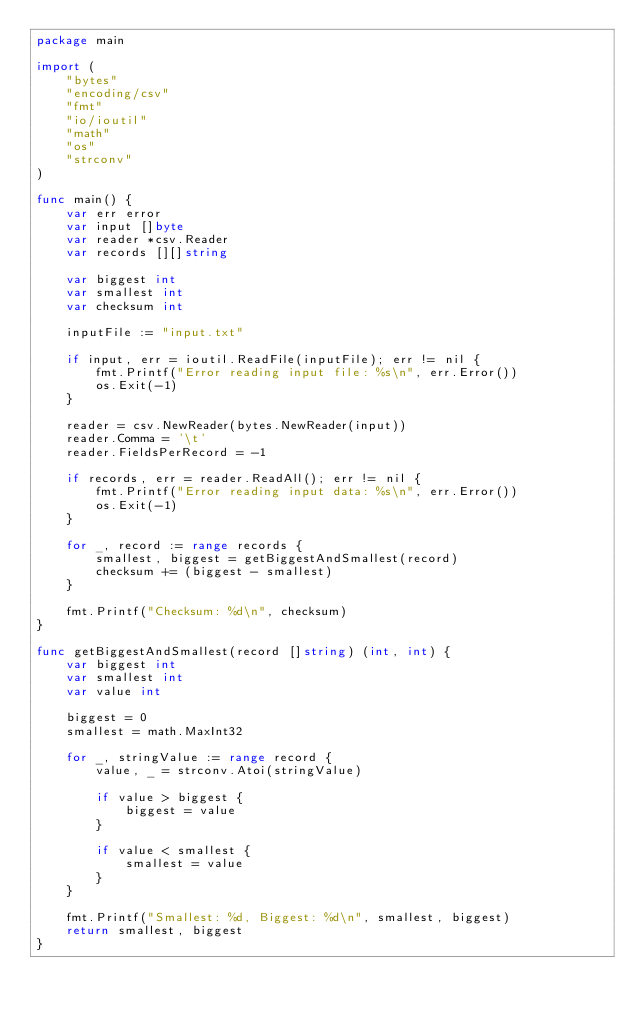<code> <loc_0><loc_0><loc_500><loc_500><_Go_>package main

import (
	"bytes"
	"encoding/csv"
	"fmt"
	"io/ioutil"
	"math"
	"os"
	"strconv"
)

func main() {
	var err error
	var input []byte
	var reader *csv.Reader
	var records [][]string

	var biggest int
	var smallest int
	var checksum int

	inputFile := "input.txt"

	if input, err = ioutil.ReadFile(inputFile); err != nil {
		fmt.Printf("Error reading input file: %s\n", err.Error())
		os.Exit(-1)
	}

	reader = csv.NewReader(bytes.NewReader(input))
	reader.Comma = '\t'
	reader.FieldsPerRecord = -1

	if records, err = reader.ReadAll(); err != nil {
		fmt.Printf("Error reading input data: %s\n", err.Error())
		os.Exit(-1)
	}

	for _, record := range records {
		smallest, biggest = getBiggestAndSmallest(record)
		checksum += (biggest - smallest)
	}

	fmt.Printf("Checksum: %d\n", checksum)
}

func getBiggestAndSmallest(record []string) (int, int) {
	var biggest int
	var smallest int
	var value int

	biggest = 0
	smallest = math.MaxInt32

	for _, stringValue := range record {
		value, _ = strconv.Atoi(stringValue)

		if value > biggest {
			biggest = value
		}

		if value < smallest {
			smallest = value
		}
	}

	fmt.Printf("Smallest: %d, Biggest: %d\n", smallest, biggest)
	return smallest, biggest
}
</code> 